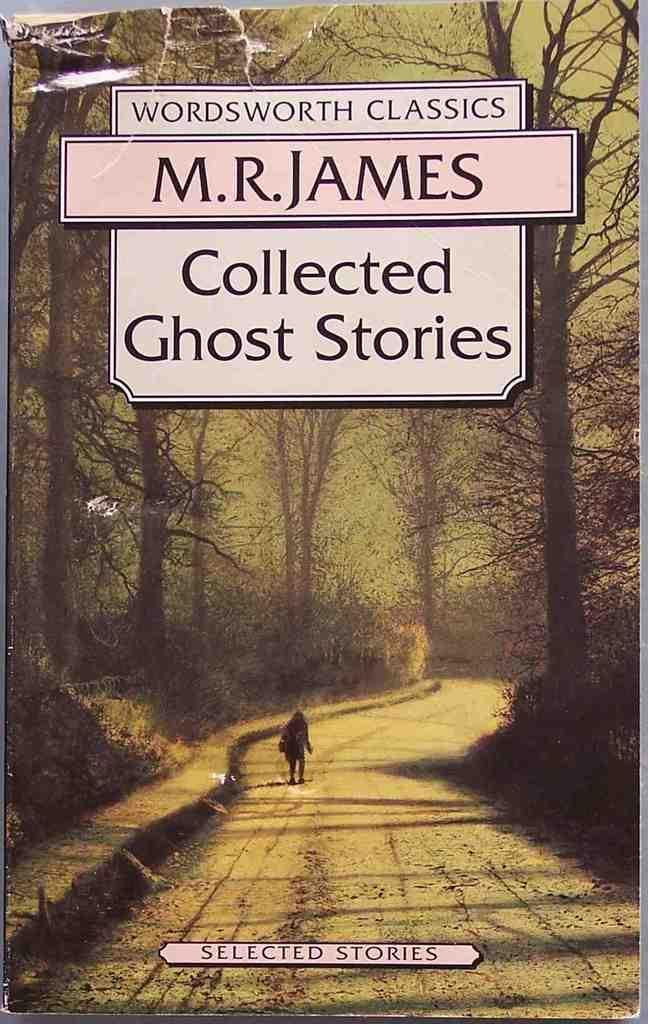Provide a one-sentence caption for the provided image. The book cover for the book Collected Ghost Stories by M.R. James. 